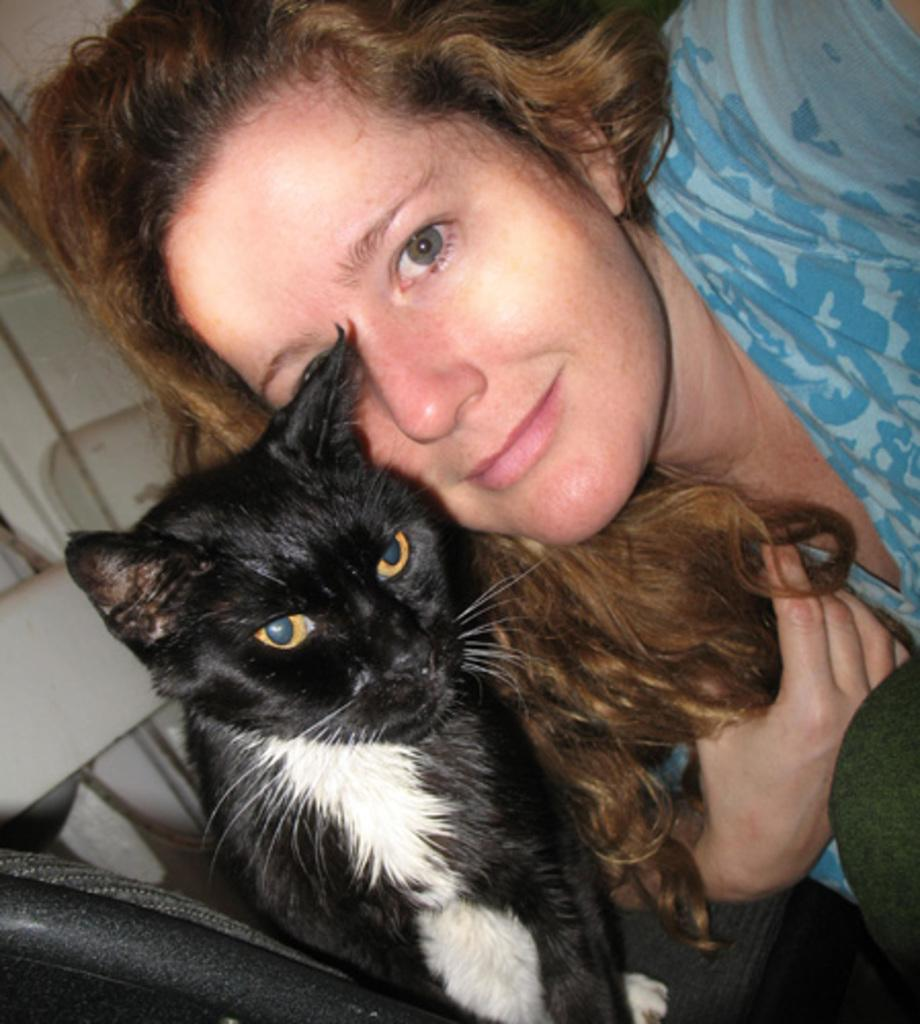Who is present in the image? There is a woman in the image. What is the woman wearing? The woman is wearing a blue dress. What is the woman holding in the image? The woman is holding a black and white cat. Can you describe the cat's appearance? The cat has yellow eyes and white whiskers. Where is the sponge located in the image? There is no sponge present in the image. What type of camp can be seen in the background of the image? There is no camp present in the image. 